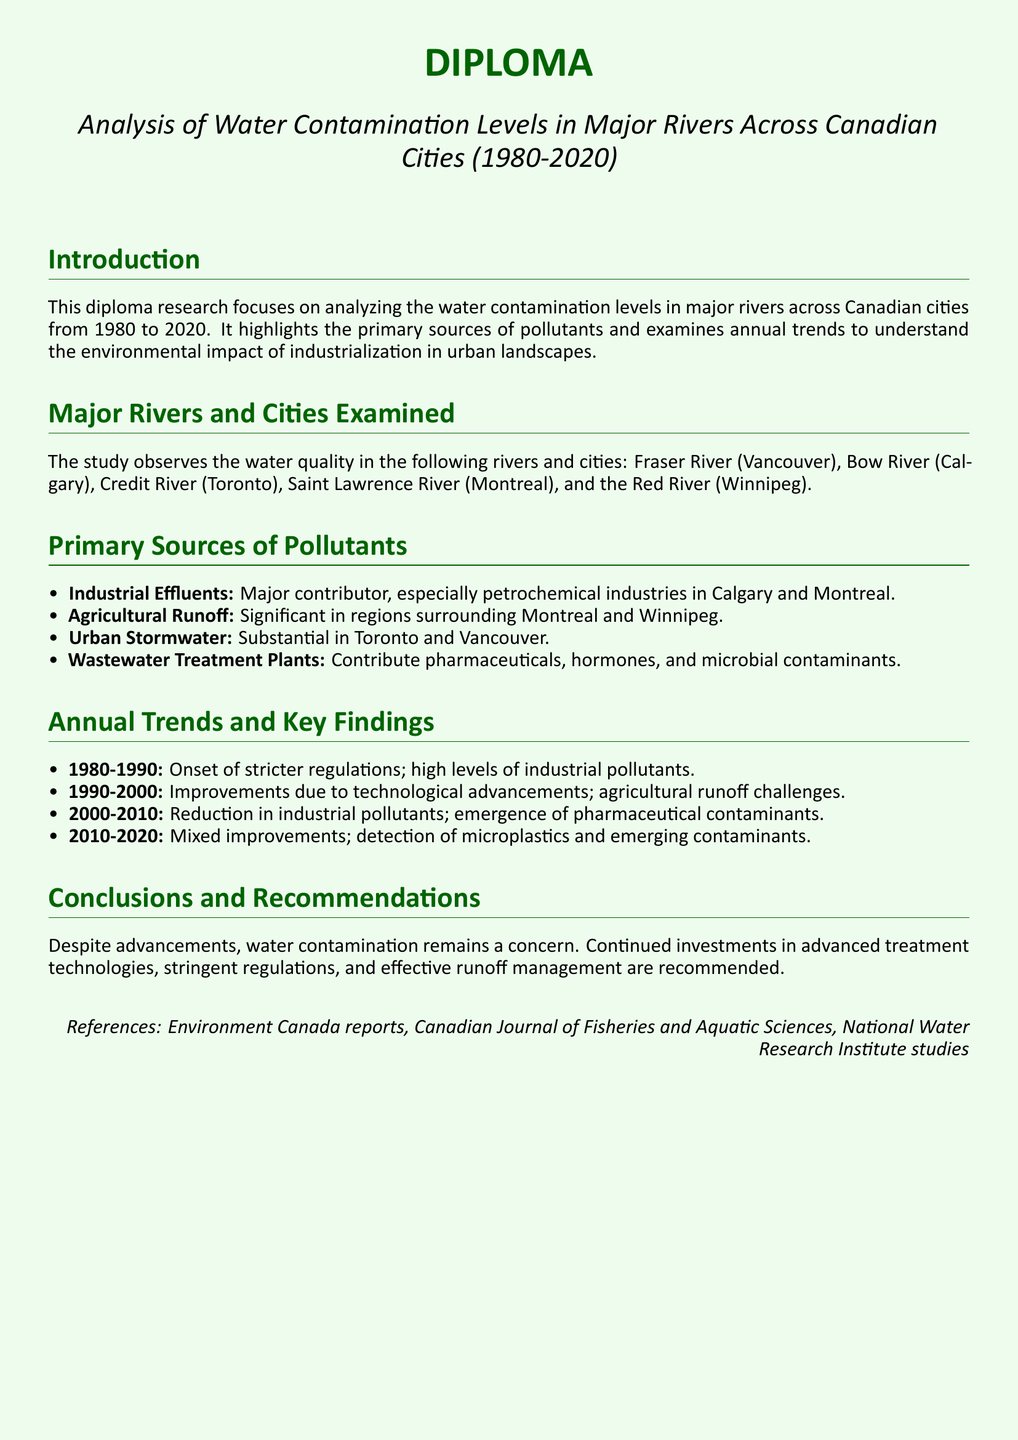what is the title of the diploma? The title of the diploma is specified in the document under the main heading.
Answer: Analysis of Water Contamination Levels in Major Rivers Across Canadian Cities (1980-2020) which rivers and cities are examined in the study? The rivers and cities observed in the study are listed in the section addressing major rivers.
Answer: Fraser River (Vancouver), Bow River (Calgary), Credit River (Toronto), Saint Lawrence River (Montreal), Red River (Winnipeg) what is the primary source of pollutants in Calgary? The document identifies the major contributor of pollution in Calgary as stated in the sources of pollutants section.
Answer: Industrial Effluents what years show improvements due to technological advancements? The trends section provides specific periods identifying improvements in pollution levels.
Answer: 1990-2000 what contaminant emerged in the 2000-2010 period? The document indicates new types of pollutants detected during this decade in the findings section.
Answer: Pharmaceutical contaminants what are the recommended actions to tackle water contamination? The document concludes with suggested approaches to manage water quality, found in the conclusions and recommendations section.
Answer: Investments in advanced treatment technologies what was the state of water contamination during 1980-1990? The trend section highlights the condition of contamination during this period.
Answer: High levels of industrial pollutants how long is the study period covered in the diploma? The study period is explicitly stated in the title of the document and can be calculated from the starting and ending years.
Answer: 40 years 